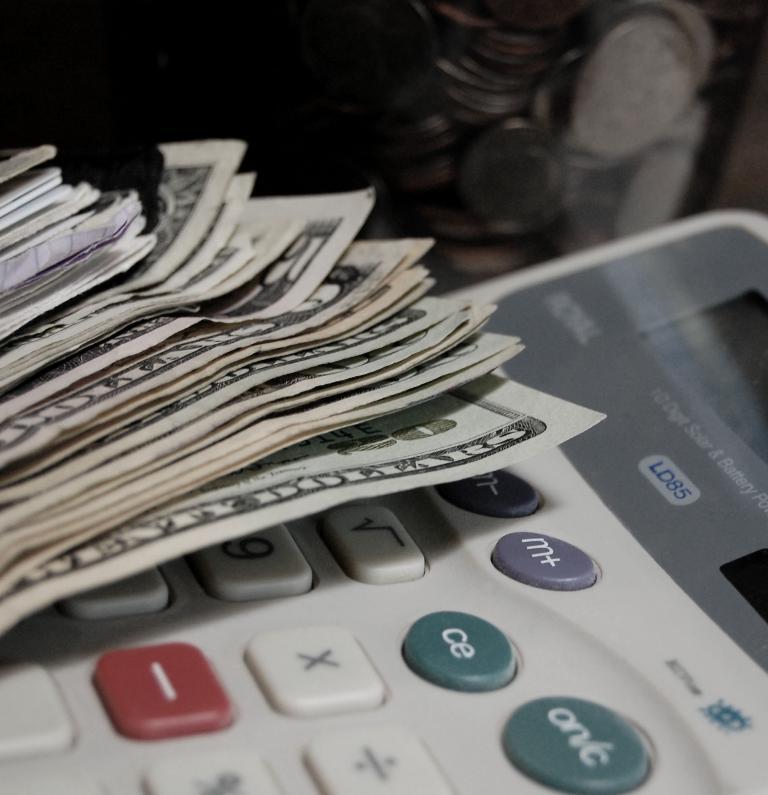What amount is on the bottom of the stack of bills?
Provide a succinct answer. 20. Are these us dollars?
Keep it short and to the point. Yes. 